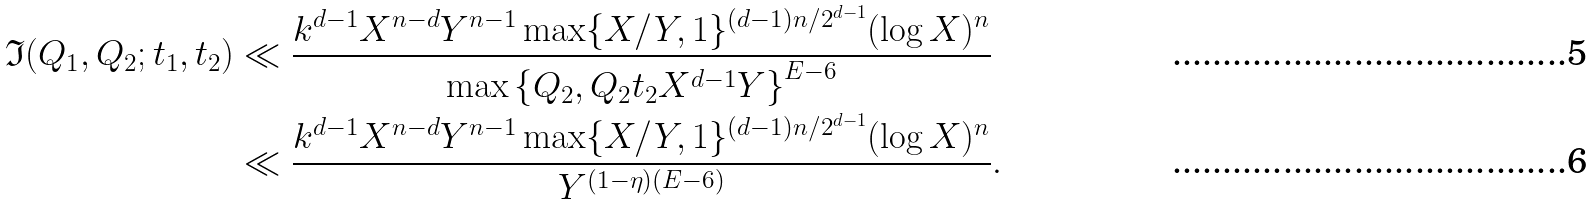<formula> <loc_0><loc_0><loc_500><loc_500>\mathfrak { I } ( Q _ { 1 } , Q _ { 2 } ; t _ { 1 } , t _ { 2 } ) & \ll \frac { k ^ { d - 1 } X ^ { n - d } Y ^ { n - 1 } \max \{ X / Y , 1 \} ^ { ( d - 1 ) n / 2 ^ { d - 1 } } ( \log X ) ^ { n } } { \max \left \{ Q _ { 2 } , Q _ { 2 } t _ { 2 } X ^ { d - 1 } Y \right \} ^ { E - 6 } } \\ & \ll \frac { k ^ { d - 1 } X ^ { n - d } Y ^ { n - 1 } \max \{ X / Y , 1 \} ^ { ( d - 1 ) n / 2 ^ { d - 1 } } ( \log X ) ^ { n } } { Y ^ { ( 1 - \eta ) ( E - 6 ) } } .</formula> 